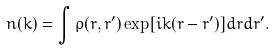<formula> <loc_0><loc_0><loc_500><loc_500>n ( k ) = \int \rho ( { r } , { r ^ { \prime } } ) \exp [ i { k } ( { r } - { r ^ { \prime } } ) ] d r d r ^ { \prime } .</formula> 